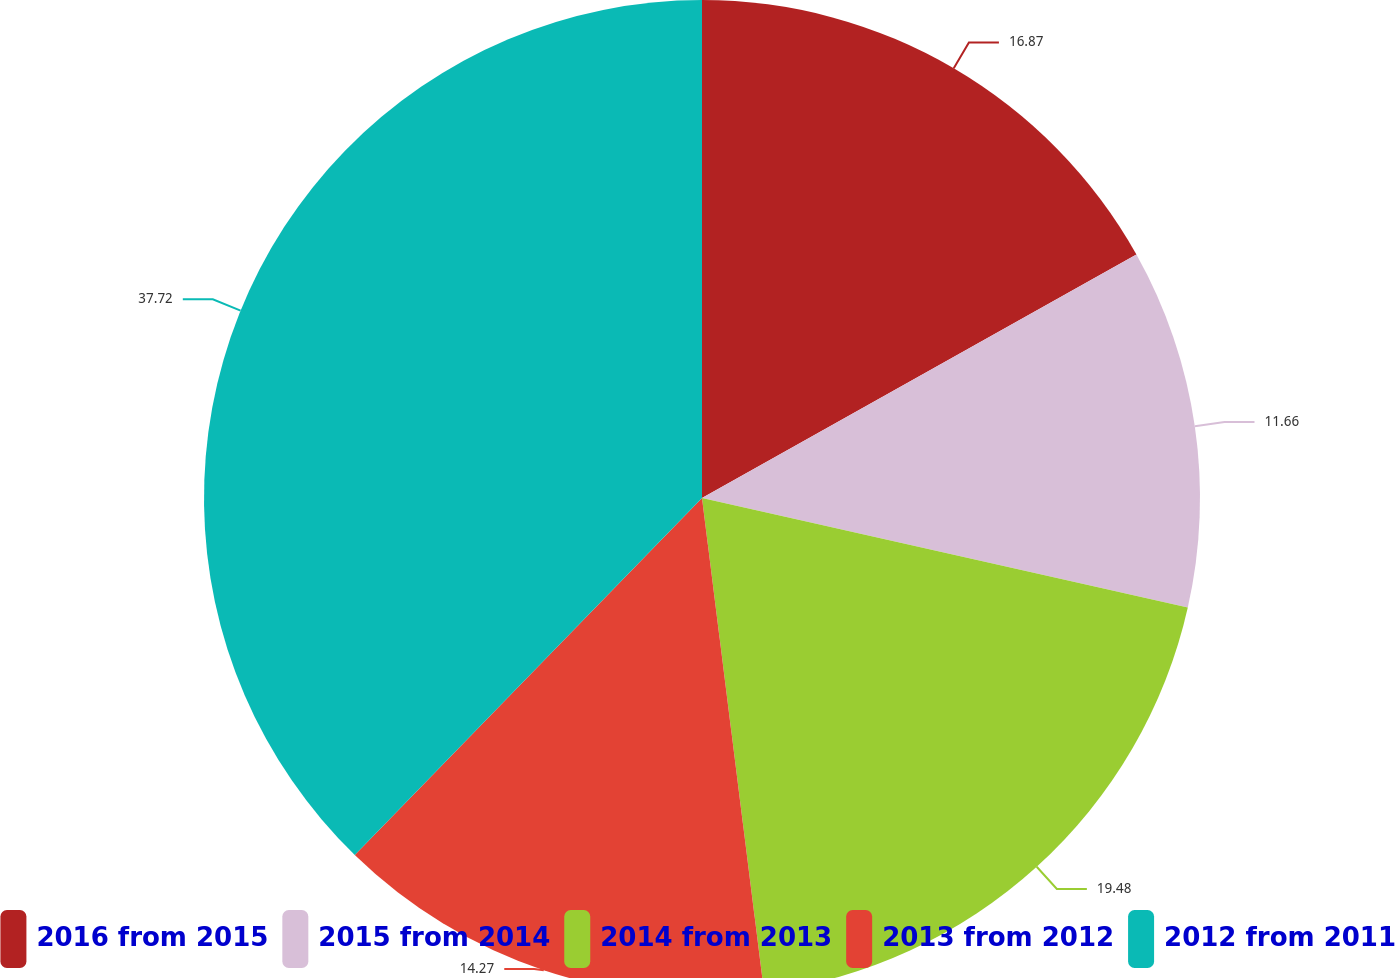Convert chart to OTSL. <chart><loc_0><loc_0><loc_500><loc_500><pie_chart><fcel>2016 from 2015<fcel>2015 from 2014<fcel>2014 from 2013<fcel>2013 from 2012<fcel>2012 from 2011<nl><fcel>16.87%<fcel>11.66%<fcel>19.48%<fcel>14.27%<fcel>37.72%<nl></chart> 